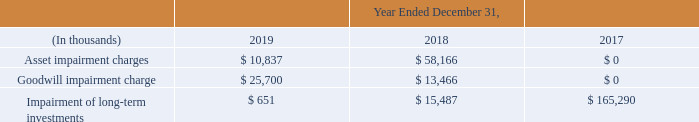8. Asset Impairment Charges
Asset impairment charges incurred during the year ended December 31, 2019 were primarily the result of impairing the remaining NantHealth acquired customer relationship intangible balance of $8.1 million. We also recognized non-cash impairment charges of $2.7 million on the retirement of certain hosting assets due to data center migrations.
Impairment of long-term investments during the year ended December 31, 2019 consisted of an impairment of $1.7 million associated with one of our long-term equity investments. We also recovered $1.0 million from one of our long-term equity investments investment that we had previously impaired. We also recorded a goodwill impairment charge of $25.7 million related to our HHS reporting unit. Refer to Note 7, “Goodwill and Intangible Assets” for further information regarding this impairment.
We incurred several non-cash asset impairment charges during the year ended December 31, 2018. We recorded non-cash asset impairment charges of $33.2 million related to the write-off of capitalized software as a result of our decision to discontinue several software development projects.
We also recorded $22.9 million of non-cash asset impairment charges related to our acquisition of the patient/provider engagement solutions business from NantHealth in 2017, which included the write-downs of $2.2 million of acquired technology and $20.7 million, representing the unamortized value assigned to the modification of our existing commercial agreement with NantHealth, as we no longer expect to recover the value assigned to these assets.
The remaining $2.1 million of non-cash asset impairment charges recorded during the year ended December 31, 2018 relate to the disposal of fixed assets as a result of relocating and consolidating business functions and locations from recent acquisitions.
We recorded a goodwill impairment charge of $13.5 million related to NantHealth during the year ended December 31, 2018. Refer to Note 7, “Goodwill and Intangible Assets” for further information regarding this impairment. We recognized non-cash impairment charges of $15.5 million in 2018 related to two of our cost-method equity investments and a related note receivable. These charges equaled the cost bases of the investments and the related note receivable prior to the impairment.
We recorded non-cash charges of $165.3 million during the year ended December 31, 2017, including impairment charges of $144.6 million associated with two of the Company’s long-term investments based on management’s assessment of the likelihood of near-term recovery of the investments’ value.
The majority of the impairment charges related to our investment in NantHealth common stock. We realized an additional $20.7 million loss upon the final disposition of the NantHealth common stock in connection with our acquisition of certain assets related to NantHealth’s provider/patient engagement solutions business. Refer to Note 4, “Business Combinations and Other Investments” and Note 14, “Accumulated Other Comprehensive Loss,” for further information regarding these impairments.
The following table summarizes the non-cash asset impairment charges recorded during the periods indicated and where they appear in the corresponding consolidated statements of operations:
What caused the asset impairment charges in 2019? Primarily the result of impairing the remaining nanthealth acquired customer relationship intangible balance of $8.1 million. What was the non-cash impairment charge in 2019? 2.7 million. What is the Goodwill impairment charge in 2019?
Answer scale should be: thousand. $ 25,700. What was the change in the asset impairment charges from 2018 to 2019?
Answer scale should be: thousand. 10,837 - 58,166
Answer: -47329. What is the average Goodwill impairment charge for 2017-2019?
Answer scale should be: thousand. (25,700 + 13,466 + 0) / 3
Answer: 13055.33. What is the change in the Impairment of long-term investments between 2017 and 2018?
Answer scale should be: thousand. 15,487 - 165,290
Answer: -149803. 